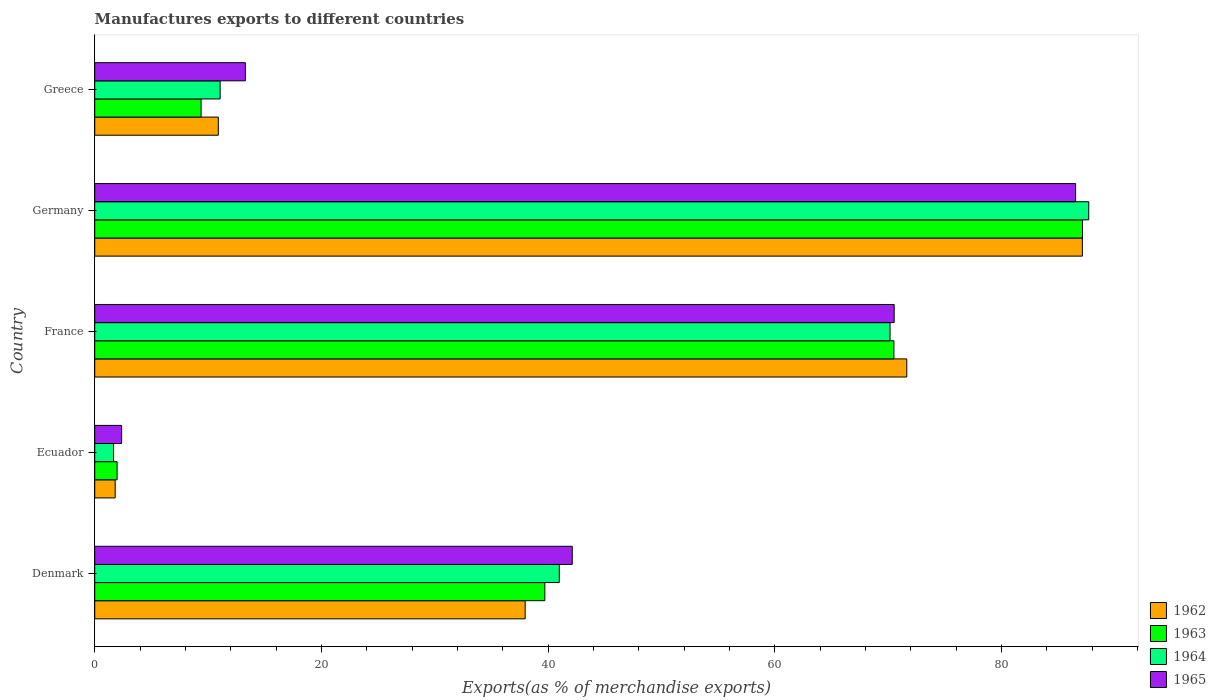Are the number of bars per tick equal to the number of legend labels?
Keep it short and to the point. Yes. How many bars are there on the 3rd tick from the bottom?
Give a very brief answer. 4. What is the label of the 5th group of bars from the top?
Provide a succinct answer. Denmark. In how many cases, is the number of bars for a given country not equal to the number of legend labels?
Make the answer very short. 0. What is the percentage of exports to different countries in 1964 in Germany?
Make the answer very short. 87.69. Across all countries, what is the maximum percentage of exports to different countries in 1965?
Your answer should be compact. 86.53. Across all countries, what is the minimum percentage of exports to different countries in 1962?
Ensure brevity in your answer.  1.8. In which country was the percentage of exports to different countries in 1965 maximum?
Your answer should be very brief. Germany. In which country was the percentage of exports to different countries in 1965 minimum?
Your response must be concise. Ecuador. What is the total percentage of exports to different countries in 1965 in the graph?
Your answer should be very brief. 214.84. What is the difference between the percentage of exports to different countries in 1964 in Denmark and that in Germany?
Offer a very short reply. -46.71. What is the difference between the percentage of exports to different countries in 1965 in France and the percentage of exports to different countries in 1962 in Denmark?
Give a very brief answer. 32.55. What is the average percentage of exports to different countries in 1964 per country?
Your answer should be very brief. 42.31. What is the difference between the percentage of exports to different countries in 1962 and percentage of exports to different countries in 1963 in Denmark?
Offer a very short reply. -1.74. In how many countries, is the percentage of exports to different countries in 1965 greater than 52 %?
Give a very brief answer. 2. What is the ratio of the percentage of exports to different countries in 1965 in Denmark to that in Germany?
Provide a succinct answer. 0.49. Is the percentage of exports to different countries in 1964 in Ecuador less than that in Germany?
Provide a short and direct response. Yes. Is the difference between the percentage of exports to different countries in 1962 in Ecuador and France greater than the difference between the percentage of exports to different countries in 1963 in Ecuador and France?
Your response must be concise. No. What is the difference between the highest and the second highest percentage of exports to different countries in 1963?
Give a very brief answer. 16.63. What is the difference between the highest and the lowest percentage of exports to different countries in 1965?
Your answer should be compact. 84.15. In how many countries, is the percentage of exports to different countries in 1962 greater than the average percentage of exports to different countries in 1962 taken over all countries?
Your response must be concise. 2. Is the sum of the percentage of exports to different countries in 1963 in Ecuador and France greater than the maximum percentage of exports to different countries in 1962 across all countries?
Your answer should be compact. No. Is it the case that in every country, the sum of the percentage of exports to different countries in 1964 and percentage of exports to different countries in 1965 is greater than the sum of percentage of exports to different countries in 1963 and percentage of exports to different countries in 1962?
Offer a very short reply. No. What does the 2nd bar from the top in France represents?
Your answer should be compact. 1964. What does the 2nd bar from the bottom in Germany represents?
Offer a very short reply. 1963. How many bars are there?
Offer a terse response. 20. Are all the bars in the graph horizontal?
Offer a terse response. Yes. What is the difference between two consecutive major ticks on the X-axis?
Offer a very short reply. 20. Where does the legend appear in the graph?
Your answer should be very brief. Bottom right. What is the title of the graph?
Ensure brevity in your answer.  Manufactures exports to different countries. What is the label or title of the X-axis?
Your response must be concise. Exports(as % of merchandise exports). What is the label or title of the Y-axis?
Provide a succinct answer. Country. What is the Exports(as % of merchandise exports) of 1962 in Denmark?
Make the answer very short. 37.97. What is the Exports(as % of merchandise exports) of 1963 in Denmark?
Your response must be concise. 39.71. What is the Exports(as % of merchandise exports) of 1964 in Denmark?
Your response must be concise. 40.98. What is the Exports(as % of merchandise exports) in 1965 in Denmark?
Provide a succinct answer. 42.12. What is the Exports(as % of merchandise exports) in 1962 in Ecuador?
Ensure brevity in your answer.  1.8. What is the Exports(as % of merchandise exports) in 1963 in Ecuador?
Provide a succinct answer. 1.97. What is the Exports(as % of merchandise exports) of 1964 in Ecuador?
Your response must be concise. 1.66. What is the Exports(as % of merchandise exports) in 1965 in Ecuador?
Your answer should be very brief. 2.37. What is the Exports(as % of merchandise exports) of 1962 in France?
Provide a short and direct response. 71.64. What is the Exports(as % of merchandise exports) in 1963 in France?
Give a very brief answer. 70.5. What is the Exports(as % of merchandise exports) of 1964 in France?
Offer a terse response. 70.16. What is the Exports(as % of merchandise exports) in 1965 in France?
Your answer should be compact. 70.52. What is the Exports(as % of merchandise exports) in 1962 in Germany?
Ensure brevity in your answer.  87.12. What is the Exports(as % of merchandise exports) in 1963 in Germany?
Offer a very short reply. 87.13. What is the Exports(as % of merchandise exports) in 1964 in Germany?
Keep it short and to the point. 87.69. What is the Exports(as % of merchandise exports) of 1965 in Germany?
Provide a short and direct response. 86.53. What is the Exports(as % of merchandise exports) in 1962 in Greece?
Your response must be concise. 10.9. What is the Exports(as % of merchandise exports) of 1963 in Greece?
Provide a short and direct response. 9.38. What is the Exports(as % of merchandise exports) of 1964 in Greece?
Keep it short and to the point. 11.06. What is the Exports(as % of merchandise exports) of 1965 in Greece?
Make the answer very short. 13.29. Across all countries, what is the maximum Exports(as % of merchandise exports) in 1962?
Offer a terse response. 87.12. Across all countries, what is the maximum Exports(as % of merchandise exports) in 1963?
Provide a succinct answer. 87.13. Across all countries, what is the maximum Exports(as % of merchandise exports) of 1964?
Provide a short and direct response. 87.69. Across all countries, what is the maximum Exports(as % of merchandise exports) in 1965?
Make the answer very short. 86.53. Across all countries, what is the minimum Exports(as % of merchandise exports) in 1962?
Your response must be concise. 1.8. Across all countries, what is the minimum Exports(as % of merchandise exports) of 1963?
Give a very brief answer. 1.97. Across all countries, what is the minimum Exports(as % of merchandise exports) in 1964?
Provide a short and direct response. 1.66. Across all countries, what is the minimum Exports(as % of merchandise exports) of 1965?
Your answer should be compact. 2.37. What is the total Exports(as % of merchandise exports) of 1962 in the graph?
Your answer should be compact. 209.44. What is the total Exports(as % of merchandise exports) in 1963 in the graph?
Your response must be concise. 208.69. What is the total Exports(as % of merchandise exports) of 1964 in the graph?
Your response must be concise. 211.55. What is the total Exports(as % of merchandise exports) in 1965 in the graph?
Offer a very short reply. 214.84. What is the difference between the Exports(as % of merchandise exports) of 1962 in Denmark and that in Ecuador?
Provide a short and direct response. 36.17. What is the difference between the Exports(as % of merchandise exports) in 1963 in Denmark and that in Ecuador?
Keep it short and to the point. 37.73. What is the difference between the Exports(as % of merchandise exports) in 1964 in Denmark and that in Ecuador?
Make the answer very short. 39.32. What is the difference between the Exports(as % of merchandise exports) in 1965 in Denmark and that in Ecuador?
Your response must be concise. 39.75. What is the difference between the Exports(as % of merchandise exports) of 1962 in Denmark and that in France?
Make the answer very short. -33.66. What is the difference between the Exports(as % of merchandise exports) of 1963 in Denmark and that in France?
Provide a succinct answer. -30.79. What is the difference between the Exports(as % of merchandise exports) of 1964 in Denmark and that in France?
Offer a terse response. -29.18. What is the difference between the Exports(as % of merchandise exports) in 1965 in Denmark and that in France?
Offer a terse response. -28.4. What is the difference between the Exports(as % of merchandise exports) in 1962 in Denmark and that in Germany?
Your answer should be very brief. -49.15. What is the difference between the Exports(as % of merchandise exports) in 1963 in Denmark and that in Germany?
Offer a terse response. -47.43. What is the difference between the Exports(as % of merchandise exports) in 1964 in Denmark and that in Germany?
Keep it short and to the point. -46.71. What is the difference between the Exports(as % of merchandise exports) in 1965 in Denmark and that in Germany?
Ensure brevity in your answer.  -44.4. What is the difference between the Exports(as % of merchandise exports) of 1962 in Denmark and that in Greece?
Make the answer very short. 27.07. What is the difference between the Exports(as % of merchandise exports) of 1963 in Denmark and that in Greece?
Offer a very short reply. 30.32. What is the difference between the Exports(as % of merchandise exports) in 1964 in Denmark and that in Greece?
Keep it short and to the point. 29.92. What is the difference between the Exports(as % of merchandise exports) in 1965 in Denmark and that in Greece?
Give a very brief answer. 28.84. What is the difference between the Exports(as % of merchandise exports) of 1962 in Ecuador and that in France?
Provide a short and direct response. -69.83. What is the difference between the Exports(as % of merchandise exports) in 1963 in Ecuador and that in France?
Your response must be concise. -68.53. What is the difference between the Exports(as % of merchandise exports) in 1964 in Ecuador and that in France?
Ensure brevity in your answer.  -68.5. What is the difference between the Exports(as % of merchandise exports) of 1965 in Ecuador and that in France?
Provide a succinct answer. -68.15. What is the difference between the Exports(as % of merchandise exports) in 1962 in Ecuador and that in Germany?
Make the answer very short. -85.32. What is the difference between the Exports(as % of merchandise exports) of 1963 in Ecuador and that in Germany?
Keep it short and to the point. -85.16. What is the difference between the Exports(as % of merchandise exports) in 1964 in Ecuador and that in Germany?
Make the answer very short. -86.02. What is the difference between the Exports(as % of merchandise exports) in 1965 in Ecuador and that in Germany?
Provide a succinct answer. -84.15. What is the difference between the Exports(as % of merchandise exports) in 1962 in Ecuador and that in Greece?
Your response must be concise. -9.1. What is the difference between the Exports(as % of merchandise exports) of 1963 in Ecuador and that in Greece?
Provide a succinct answer. -7.41. What is the difference between the Exports(as % of merchandise exports) of 1964 in Ecuador and that in Greece?
Make the answer very short. -9.4. What is the difference between the Exports(as % of merchandise exports) in 1965 in Ecuador and that in Greece?
Make the answer very short. -10.91. What is the difference between the Exports(as % of merchandise exports) in 1962 in France and that in Germany?
Provide a succinct answer. -15.49. What is the difference between the Exports(as % of merchandise exports) in 1963 in France and that in Germany?
Keep it short and to the point. -16.63. What is the difference between the Exports(as % of merchandise exports) in 1964 in France and that in Germany?
Offer a terse response. -17.53. What is the difference between the Exports(as % of merchandise exports) in 1965 in France and that in Germany?
Keep it short and to the point. -16.01. What is the difference between the Exports(as % of merchandise exports) of 1962 in France and that in Greece?
Make the answer very short. 60.73. What is the difference between the Exports(as % of merchandise exports) in 1963 in France and that in Greece?
Provide a short and direct response. 61.12. What is the difference between the Exports(as % of merchandise exports) of 1964 in France and that in Greece?
Make the answer very short. 59.1. What is the difference between the Exports(as % of merchandise exports) in 1965 in France and that in Greece?
Provide a succinct answer. 57.23. What is the difference between the Exports(as % of merchandise exports) of 1962 in Germany and that in Greece?
Offer a terse response. 76.22. What is the difference between the Exports(as % of merchandise exports) in 1963 in Germany and that in Greece?
Make the answer very short. 77.75. What is the difference between the Exports(as % of merchandise exports) in 1964 in Germany and that in Greece?
Offer a very short reply. 76.62. What is the difference between the Exports(as % of merchandise exports) in 1965 in Germany and that in Greece?
Ensure brevity in your answer.  73.24. What is the difference between the Exports(as % of merchandise exports) in 1962 in Denmark and the Exports(as % of merchandise exports) in 1963 in Ecuador?
Give a very brief answer. 36. What is the difference between the Exports(as % of merchandise exports) of 1962 in Denmark and the Exports(as % of merchandise exports) of 1964 in Ecuador?
Ensure brevity in your answer.  36.31. What is the difference between the Exports(as % of merchandise exports) in 1962 in Denmark and the Exports(as % of merchandise exports) in 1965 in Ecuador?
Keep it short and to the point. 35.6. What is the difference between the Exports(as % of merchandise exports) in 1963 in Denmark and the Exports(as % of merchandise exports) in 1964 in Ecuador?
Provide a short and direct response. 38.04. What is the difference between the Exports(as % of merchandise exports) of 1963 in Denmark and the Exports(as % of merchandise exports) of 1965 in Ecuador?
Offer a terse response. 37.33. What is the difference between the Exports(as % of merchandise exports) in 1964 in Denmark and the Exports(as % of merchandise exports) in 1965 in Ecuador?
Make the answer very short. 38.61. What is the difference between the Exports(as % of merchandise exports) of 1962 in Denmark and the Exports(as % of merchandise exports) of 1963 in France?
Provide a short and direct response. -32.53. What is the difference between the Exports(as % of merchandise exports) in 1962 in Denmark and the Exports(as % of merchandise exports) in 1964 in France?
Your answer should be compact. -32.19. What is the difference between the Exports(as % of merchandise exports) in 1962 in Denmark and the Exports(as % of merchandise exports) in 1965 in France?
Your response must be concise. -32.55. What is the difference between the Exports(as % of merchandise exports) in 1963 in Denmark and the Exports(as % of merchandise exports) in 1964 in France?
Your answer should be very brief. -30.45. What is the difference between the Exports(as % of merchandise exports) of 1963 in Denmark and the Exports(as % of merchandise exports) of 1965 in France?
Make the answer very short. -30.82. What is the difference between the Exports(as % of merchandise exports) of 1964 in Denmark and the Exports(as % of merchandise exports) of 1965 in France?
Keep it short and to the point. -29.54. What is the difference between the Exports(as % of merchandise exports) of 1962 in Denmark and the Exports(as % of merchandise exports) of 1963 in Germany?
Offer a very short reply. -49.16. What is the difference between the Exports(as % of merchandise exports) of 1962 in Denmark and the Exports(as % of merchandise exports) of 1964 in Germany?
Offer a terse response. -49.71. What is the difference between the Exports(as % of merchandise exports) of 1962 in Denmark and the Exports(as % of merchandise exports) of 1965 in Germany?
Ensure brevity in your answer.  -48.56. What is the difference between the Exports(as % of merchandise exports) of 1963 in Denmark and the Exports(as % of merchandise exports) of 1964 in Germany?
Give a very brief answer. -47.98. What is the difference between the Exports(as % of merchandise exports) of 1963 in Denmark and the Exports(as % of merchandise exports) of 1965 in Germany?
Offer a very short reply. -46.82. What is the difference between the Exports(as % of merchandise exports) of 1964 in Denmark and the Exports(as % of merchandise exports) of 1965 in Germany?
Offer a terse response. -45.55. What is the difference between the Exports(as % of merchandise exports) of 1962 in Denmark and the Exports(as % of merchandise exports) of 1963 in Greece?
Offer a very short reply. 28.59. What is the difference between the Exports(as % of merchandise exports) of 1962 in Denmark and the Exports(as % of merchandise exports) of 1964 in Greece?
Provide a succinct answer. 26.91. What is the difference between the Exports(as % of merchandise exports) in 1962 in Denmark and the Exports(as % of merchandise exports) in 1965 in Greece?
Provide a succinct answer. 24.68. What is the difference between the Exports(as % of merchandise exports) in 1963 in Denmark and the Exports(as % of merchandise exports) in 1964 in Greece?
Ensure brevity in your answer.  28.64. What is the difference between the Exports(as % of merchandise exports) in 1963 in Denmark and the Exports(as % of merchandise exports) in 1965 in Greece?
Make the answer very short. 26.42. What is the difference between the Exports(as % of merchandise exports) of 1964 in Denmark and the Exports(as % of merchandise exports) of 1965 in Greece?
Keep it short and to the point. 27.69. What is the difference between the Exports(as % of merchandise exports) in 1962 in Ecuador and the Exports(as % of merchandise exports) in 1963 in France?
Offer a terse response. -68.7. What is the difference between the Exports(as % of merchandise exports) of 1962 in Ecuador and the Exports(as % of merchandise exports) of 1964 in France?
Ensure brevity in your answer.  -68.35. What is the difference between the Exports(as % of merchandise exports) of 1962 in Ecuador and the Exports(as % of merchandise exports) of 1965 in France?
Keep it short and to the point. -68.72. What is the difference between the Exports(as % of merchandise exports) of 1963 in Ecuador and the Exports(as % of merchandise exports) of 1964 in France?
Your response must be concise. -68.18. What is the difference between the Exports(as % of merchandise exports) in 1963 in Ecuador and the Exports(as % of merchandise exports) in 1965 in France?
Keep it short and to the point. -68.55. What is the difference between the Exports(as % of merchandise exports) of 1964 in Ecuador and the Exports(as % of merchandise exports) of 1965 in France?
Your answer should be compact. -68.86. What is the difference between the Exports(as % of merchandise exports) in 1962 in Ecuador and the Exports(as % of merchandise exports) in 1963 in Germany?
Your answer should be very brief. -85.33. What is the difference between the Exports(as % of merchandise exports) in 1962 in Ecuador and the Exports(as % of merchandise exports) in 1964 in Germany?
Provide a short and direct response. -85.88. What is the difference between the Exports(as % of merchandise exports) of 1962 in Ecuador and the Exports(as % of merchandise exports) of 1965 in Germany?
Ensure brevity in your answer.  -84.72. What is the difference between the Exports(as % of merchandise exports) in 1963 in Ecuador and the Exports(as % of merchandise exports) in 1964 in Germany?
Keep it short and to the point. -85.71. What is the difference between the Exports(as % of merchandise exports) of 1963 in Ecuador and the Exports(as % of merchandise exports) of 1965 in Germany?
Your answer should be compact. -84.55. What is the difference between the Exports(as % of merchandise exports) in 1964 in Ecuador and the Exports(as % of merchandise exports) in 1965 in Germany?
Your answer should be very brief. -84.87. What is the difference between the Exports(as % of merchandise exports) of 1962 in Ecuador and the Exports(as % of merchandise exports) of 1963 in Greece?
Ensure brevity in your answer.  -7.58. What is the difference between the Exports(as % of merchandise exports) in 1962 in Ecuador and the Exports(as % of merchandise exports) in 1964 in Greece?
Offer a very short reply. -9.26. What is the difference between the Exports(as % of merchandise exports) of 1962 in Ecuador and the Exports(as % of merchandise exports) of 1965 in Greece?
Your response must be concise. -11.48. What is the difference between the Exports(as % of merchandise exports) in 1963 in Ecuador and the Exports(as % of merchandise exports) in 1964 in Greece?
Give a very brief answer. -9.09. What is the difference between the Exports(as % of merchandise exports) of 1963 in Ecuador and the Exports(as % of merchandise exports) of 1965 in Greece?
Offer a very short reply. -11.31. What is the difference between the Exports(as % of merchandise exports) in 1964 in Ecuador and the Exports(as % of merchandise exports) in 1965 in Greece?
Offer a very short reply. -11.63. What is the difference between the Exports(as % of merchandise exports) of 1962 in France and the Exports(as % of merchandise exports) of 1963 in Germany?
Ensure brevity in your answer.  -15.5. What is the difference between the Exports(as % of merchandise exports) of 1962 in France and the Exports(as % of merchandise exports) of 1964 in Germany?
Give a very brief answer. -16.05. What is the difference between the Exports(as % of merchandise exports) in 1962 in France and the Exports(as % of merchandise exports) in 1965 in Germany?
Your response must be concise. -14.89. What is the difference between the Exports(as % of merchandise exports) of 1963 in France and the Exports(as % of merchandise exports) of 1964 in Germany?
Ensure brevity in your answer.  -17.18. What is the difference between the Exports(as % of merchandise exports) in 1963 in France and the Exports(as % of merchandise exports) in 1965 in Germany?
Make the answer very short. -16.03. What is the difference between the Exports(as % of merchandise exports) in 1964 in France and the Exports(as % of merchandise exports) in 1965 in Germany?
Give a very brief answer. -16.37. What is the difference between the Exports(as % of merchandise exports) of 1962 in France and the Exports(as % of merchandise exports) of 1963 in Greece?
Your response must be concise. 62.25. What is the difference between the Exports(as % of merchandise exports) in 1962 in France and the Exports(as % of merchandise exports) in 1964 in Greece?
Provide a succinct answer. 60.57. What is the difference between the Exports(as % of merchandise exports) of 1962 in France and the Exports(as % of merchandise exports) of 1965 in Greece?
Offer a terse response. 58.35. What is the difference between the Exports(as % of merchandise exports) in 1963 in France and the Exports(as % of merchandise exports) in 1964 in Greece?
Your answer should be very brief. 59.44. What is the difference between the Exports(as % of merchandise exports) in 1963 in France and the Exports(as % of merchandise exports) in 1965 in Greece?
Provide a succinct answer. 57.21. What is the difference between the Exports(as % of merchandise exports) in 1964 in France and the Exports(as % of merchandise exports) in 1965 in Greece?
Offer a very short reply. 56.87. What is the difference between the Exports(as % of merchandise exports) in 1962 in Germany and the Exports(as % of merchandise exports) in 1963 in Greece?
Your response must be concise. 77.74. What is the difference between the Exports(as % of merchandise exports) in 1962 in Germany and the Exports(as % of merchandise exports) in 1964 in Greece?
Your response must be concise. 76.06. What is the difference between the Exports(as % of merchandise exports) of 1962 in Germany and the Exports(as % of merchandise exports) of 1965 in Greece?
Offer a terse response. 73.84. What is the difference between the Exports(as % of merchandise exports) in 1963 in Germany and the Exports(as % of merchandise exports) in 1964 in Greece?
Ensure brevity in your answer.  76.07. What is the difference between the Exports(as % of merchandise exports) of 1963 in Germany and the Exports(as % of merchandise exports) of 1965 in Greece?
Your response must be concise. 73.84. What is the difference between the Exports(as % of merchandise exports) of 1964 in Germany and the Exports(as % of merchandise exports) of 1965 in Greece?
Give a very brief answer. 74.4. What is the average Exports(as % of merchandise exports) of 1962 per country?
Make the answer very short. 41.89. What is the average Exports(as % of merchandise exports) in 1963 per country?
Make the answer very short. 41.74. What is the average Exports(as % of merchandise exports) in 1964 per country?
Your response must be concise. 42.31. What is the average Exports(as % of merchandise exports) in 1965 per country?
Your response must be concise. 42.97. What is the difference between the Exports(as % of merchandise exports) in 1962 and Exports(as % of merchandise exports) in 1963 in Denmark?
Offer a very short reply. -1.74. What is the difference between the Exports(as % of merchandise exports) of 1962 and Exports(as % of merchandise exports) of 1964 in Denmark?
Offer a very short reply. -3.01. What is the difference between the Exports(as % of merchandise exports) of 1962 and Exports(as % of merchandise exports) of 1965 in Denmark?
Keep it short and to the point. -4.15. What is the difference between the Exports(as % of merchandise exports) in 1963 and Exports(as % of merchandise exports) in 1964 in Denmark?
Offer a terse response. -1.27. What is the difference between the Exports(as % of merchandise exports) in 1963 and Exports(as % of merchandise exports) in 1965 in Denmark?
Your response must be concise. -2.42. What is the difference between the Exports(as % of merchandise exports) in 1964 and Exports(as % of merchandise exports) in 1965 in Denmark?
Offer a very short reply. -1.14. What is the difference between the Exports(as % of merchandise exports) of 1962 and Exports(as % of merchandise exports) of 1963 in Ecuador?
Offer a very short reply. -0.17. What is the difference between the Exports(as % of merchandise exports) of 1962 and Exports(as % of merchandise exports) of 1964 in Ecuador?
Provide a short and direct response. 0.14. What is the difference between the Exports(as % of merchandise exports) of 1962 and Exports(as % of merchandise exports) of 1965 in Ecuador?
Provide a short and direct response. -0.57. What is the difference between the Exports(as % of merchandise exports) of 1963 and Exports(as % of merchandise exports) of 1964 in Ecuador?
Provide a succinct answer. 0.31. What is the difference between the Exports(as % of merchandise exports) in 1963 and Exports(as % of merchandise exports) in 1965 in Ecuador?
Offer a very short reply. -0.4. What is the difference between the Exports(as % of merchandise exports) in 1964 and Exports(as % of merchandise exports) in 1965 in Ecuador?
Offer a very short reply. -0.71. What is the difference between the Exports(as % of merchandise exports) of 1962 and Exports(as % of merchandise exports) of 1963 in France?
Keep it short and to the point. 1.13. What is the difference between the Exports(as % of merchandise exports) of 1962 and Exports(as % of merchandise exports) of 1964 in France?
Ensure brevity in your answer.  1.48. What is the difference between the Exports(as % of merchandise exports) in 1962 and Exports(as % of merchandise exports) in 1965 in France?
Your response must be concise. 1.11. What is the difference between the Exports(as % of merchandise exports) in 1963 and Exports(as % of merchandise exports) in 1964 in France?
Keep it short and to the point. 0.34. What is the difference between the Exports(as % of merchandise exports) in 1963 and Exports(as % of merchandise exports) in 1965 in France?
Offer a terse response. -0.02. What is the difference between the Exports(as % of merchandise exports) of 1964 and Exports(as % of merchandise exports) of 1965 in France?
Your answer should be compact. -0.36. What is the difference between the Exports(as % of merchandise exports) in 1962 and Exports(as % of merchandise exports) in 1963 in Germany?
Ensure brevity in your answer.  -0.01. What is the difference between the Exports(as % of merchandise exports) in 1962 and Exports(as % of merchandise exports) in 1964 in Germany?
Your answer should be compact. -0.56. What is the difference between the Exports(as % of merchandise exports) of 1962 and Exports(as % of merchandise exports) of 1965 in Germany?
Your answer should be compact. 0.6. What is the difference between the Exports(as % of merchandise exports) of 1963 and Exports(as % of merchandise exports) of 1964 in Germany?
Your response must be concise. -0.55. What is the difference between the Exports(as % of merchandise exports) of 1963 and Exports(as % of merchandise exports) of 1965 in Germany?
Offer a terse response. 0.6. What is the difference between the Exports(as % of merchandise exports) of 1964 and Exports(as % of merchandise exports) of 1965 in Germany?
Make the answer very short. 1.16. What is the difference between the Exports(as % of merchandise exports) of 1962 and Exports(as % of merchandise exports) of 1963 in Greece?
Provide a short and direct response. 1.52. What is the difference between the Exports(as % of merchandise exports) in 1962 and Exports(as % of merchandise exports) in 1964 in Greece?
Your response must be concise. -0.16. What is the difference between the Exports(as % of merchandise exports) of 1962 and Exports(as % of merchandise exports) of 1965 in Greece?
Your answer should be compact. -2.39. What is the difference between the Exports(as % of merchandise exports) of 1963 and Exports(as % of merchandise exports) of 1964 in Greece?
Your response must be concise. -1.68. What is the difference between the Exports(as % of merchandise exports) of 1963 and Exports(as % of merchandise exports) of 1965 in Greece?
Your response must be concise. -3.91. What is the difference between the Exports(as % of merchandise exports) of 1964 and Exports(as % of merchandise exports) of 1965 in Greece?
Your answer should be compact. -2.23. What is the ratio of the Exports(as % of merchandise exports) of 1962 in Denmark to that in Ecuador?
Your response must be concise. 21.05. What is the ratio of the Exports(as % of merchandise exports) of 1963 in Denmark to that in Ecuador?
Your response must be concise. 20.11. What is the ratio of the Exports(as % of merchandise exports) of 1964 in Denmark to that in Ecuador?
Make the answer very short. 24.64. What is the ratio of the Exports(as % of merchandise exports) of 1965 in Denmark to that in Ecuador?
Your response must be concise. 17.75. What is the ratio of the Exports(as % of merchandise exports) of 1962 in Denmark to that in France?
Keep it short and to the point. 0.53. What is the ratio of the Exports(as % of merchandise exports) of 1963 in Denmark to that in France?
Offer a terse response. 0.56. What is the ratio of the Exports(as % of merchandise exports) in 1964 in Denmark to that in France?
Offer a terse response. 0.58. What is the ratio of the Exports(as % of merchandise exports) of 1965 in Denmark to that in France?
Ensure brevity in your answer.  0.6. What is the ratio of the Exports(as % of merchandise exports) in 1962 in Denmark to that in Germany?
Give a very brief answer. 0.44. What is the ratio of the Exports(as % of merchandise exports) of 1963 in Denmark to that in Germany?
Your answer should be compact. 0.46. What is the ratio of the Exports(as % of merchandise exports) in 1964 in Denmark to that in Germany?
Offer a very short reply. 0.47. What is the ratio of the Exports(as % of merchandise exports) in 1965 in Denmark to that in Germany?
Your answer should be compact. 0.49. What is the ratio of the Exports(as % of merchandise exports) of 1962 in Denmark to that in Greece?
Provide a succinct answer. 3.48. What is the ratio of the Exports(as % of merchandise exports) of 1963 in Denmark to that in Greece?
Your answer should be compact. 4.23. What is the ratio of the Exports(as % of merchandise exports) in 1964 in Denmark to that in Greece?
Keep it short and to the point. 3.7. What is the ratio of the Exports(as % of merchandise exports) in 1965 in Denmark to that in Greece?
Give a very brief answer. 3.17. What is the ratio of the Exports(as % of merchandise exports) in 1962 in Ecuador to that in France?
Offer a very short reply. 0.03. What is the ratio of the Exports(as % of merchandise exports) of 1963 in Ecuador to that in France?
Your response must be concise. 0.03. What is the ratio of the Exports(as % of merchandise exports) of 1964 in Ecuador to that in France?
Give a very brief answer. 0.02. What is the ratio of the Exports(as % of merchandise exports) in 1965 in Ecuador to that in France?
Your response must be concise. 0.03. What is the ratio of the Exports(as % of merchandise exports) in 1962 in Ecuador to that in Germany?
Make the answer very short. 0.02. What is the ratio of the Exports(as % of merchandise exports) of 1963 in Ecuador to that in Germany?
Offer a very short reply. 0.02. What is the ratio of the Exports(as % of merchandise exports) in 1964 in Ecuador to that in Germany?
Provide a succinct answer. 0.02. What is the ratio of the Exports(as % of merchandise exports) in 1965 in Ecuador to that in Germany?
Your answer should be compact. 0.03. What is the ratio of the Exports(as % of merchandise exports) in 1962 in Ecuador to that in Greece?
Keep it short and to the point. 0.17. What is the ratio of the Exports(as % of merchandise exports) in 1963 in Ecuador to that in Greece?
Ensure brevity in your answer.  0.21. What is the ratio of the Exports(as % of merchandise exports) in 1964 in Ecuador to that in Greece?
Ensure brevity in your answer.  0.15. What is the ratio of the Exports(as % of merchandise exports) in 1965 in Ecuador to that in Greece?
Give a very brief answer. 0.18. What is the ratio of the Exports(as % of merchandise exports) of 1962 in France to that in Germany?
Offer a terse response. 0.82. What is the ratio of the Exports(as % of merchandise exports) in 1963 in France to that in Germany?
Keep it short and to the point. 0.81. What is the ratio of the Exports(as % of merchandise exports) of 1964 in France to that in Germany?
Your answer should be very brief. 0.8. What is the ratio of the Exports(as % of merchandise exports) in 1965 in France to that in Germany?
Offer a terse response. 0.81. What is the ratio of the Exports(as % of merchandise exports) of 1962 in France to that in Greece?
Provide a succinct answer. 6.57. What is the ratio of the Exports(as % of merchandise exports) of 1963 in France to that in Greece?
Keep it short and to the point. 7.51. What is the ratio of the Exports(as % of merchandise exports) of 1964 in France to that in Greece?
Ensure brevity in your answer.  6.34. What is the ratio of the Exports(as % of merchandise exports) in 1965 in France to that in Greece?
Provide a short and direct response. 5.31. What is the ratio of the Exports(as % of merchandise exports) in 1962 in Germany to that in Greece?
Offer a terse response. 7.99. What is the ratio of the Exports(as % of merchandise exports) in 1963 in Germany to that in Greece?
Offer a very short reply. 9.29. What is the ratio of the Exports(as % of merchandise exports) in 1964 in Germany to that in Greece?
Make the answer very short. 7.93. What is the ratio of the Exports(as % of merchandise exports) in 1965 in Germany to that in Greece?
Provide a succinct answer. 6.51. What is the difference between the highest and the second highest Exports(as % of merchandise exports) in 1962?
Make the answer very short. 15.49. What is the difference between the highest and the second highest Exports(as % of merchandise exports) in 1963?
Ensure brevity in your answer.  16.63. What is the difference between the highest and the second highest Exports(as % of merchandise exports) of 1964?
Provide a short and direct response. 17.53. What is the difference between the highest and the second highest Exports(as % of merchandise exports) of 1965?
Your answer should be compact. 16.01. What is the difference between the highest and the lowest Exports(as % of merchandise exports) of 1962?
Keep it short and to the point. 85.32. What is the difference between the highest and the lowest Exports(as % of merchandise exports) in 1963?
Your answer should be very brief. 85.16. What is the difference between the highest and the lowest Exports(as % of merchandise exports) of 1964?
Your answer should be compact. 86.02. What is the difference between the highest and the lowest Exports(as % of merchandise exports) in 1965?
Keep it short and to the point. 84.15. 